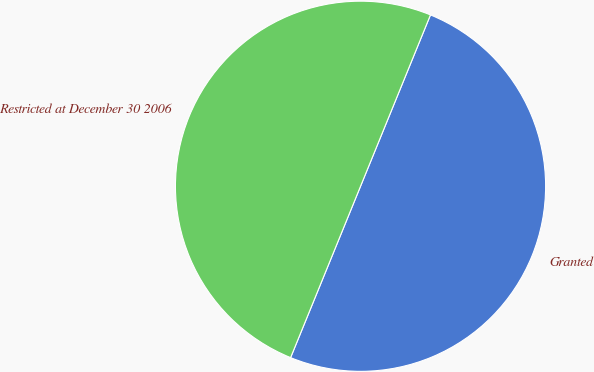<chart> <loc_0><loc_0><loc_500><loc_500><pie_chart><fcel>Granted<fcel>Restricted at December 30 2006<nl><fcel>50.0%<fcel>50.0%<nl></chart> 